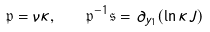<formula> <loc_0><loc_0><loc_500><loc_500>\mathfrak { p } = \nu \kappa , \quad \mathfrak { p } ^ { - 1 } \mathfrak { s } = \partial _ { y _ { 1 } } ( \ln \kappa J )</formula> 